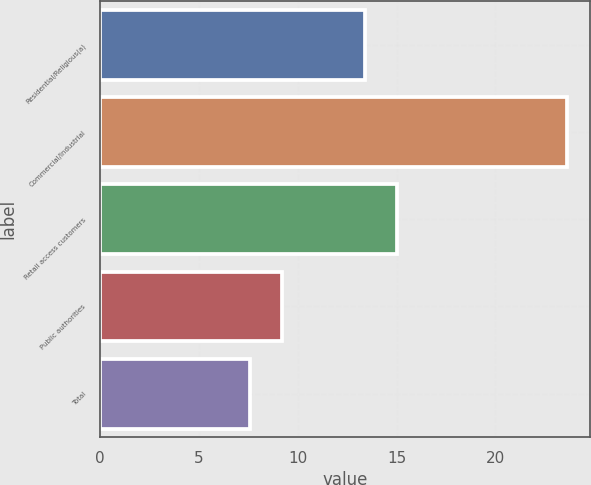Convert chart to OTSL. <chart><loc_0><loc_0><loc_500><loc_500><bar_chart><fcel>Residential/Religious(a)<fcel>Commercial/Industrial<fcel>Retail access customers<fcel>Public authorities<fcel>Total<nl><fcel>13.4<fcel>23.6<fcel>15<fcel>9.2<fcel>7.6<nl></chart> 